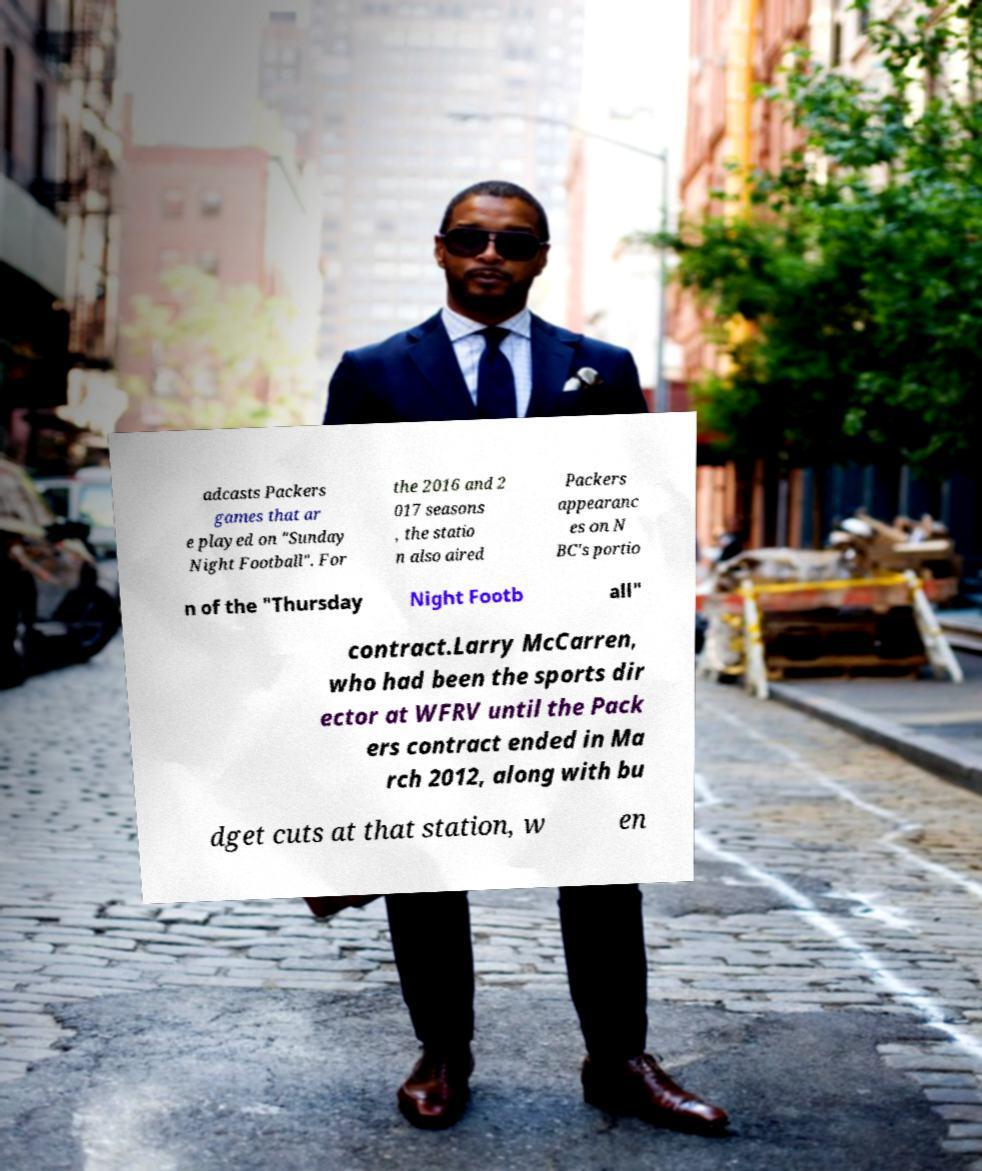Could you assist in decoding the text presented in this image and type it out clearly? adcasts Packers games that ar e played on "Sunday Night Football". For the 2016 and 2 017 seasons , the statio n also aired Packers appearanc es on N BC's portio n of the "Thursday Night Footb all" contract.Larry McCarren, who had been the sports dir ector at WFRV until the Pack ers contract ended in Ma rch 2012, along with bu dget cuts at that station, w en 